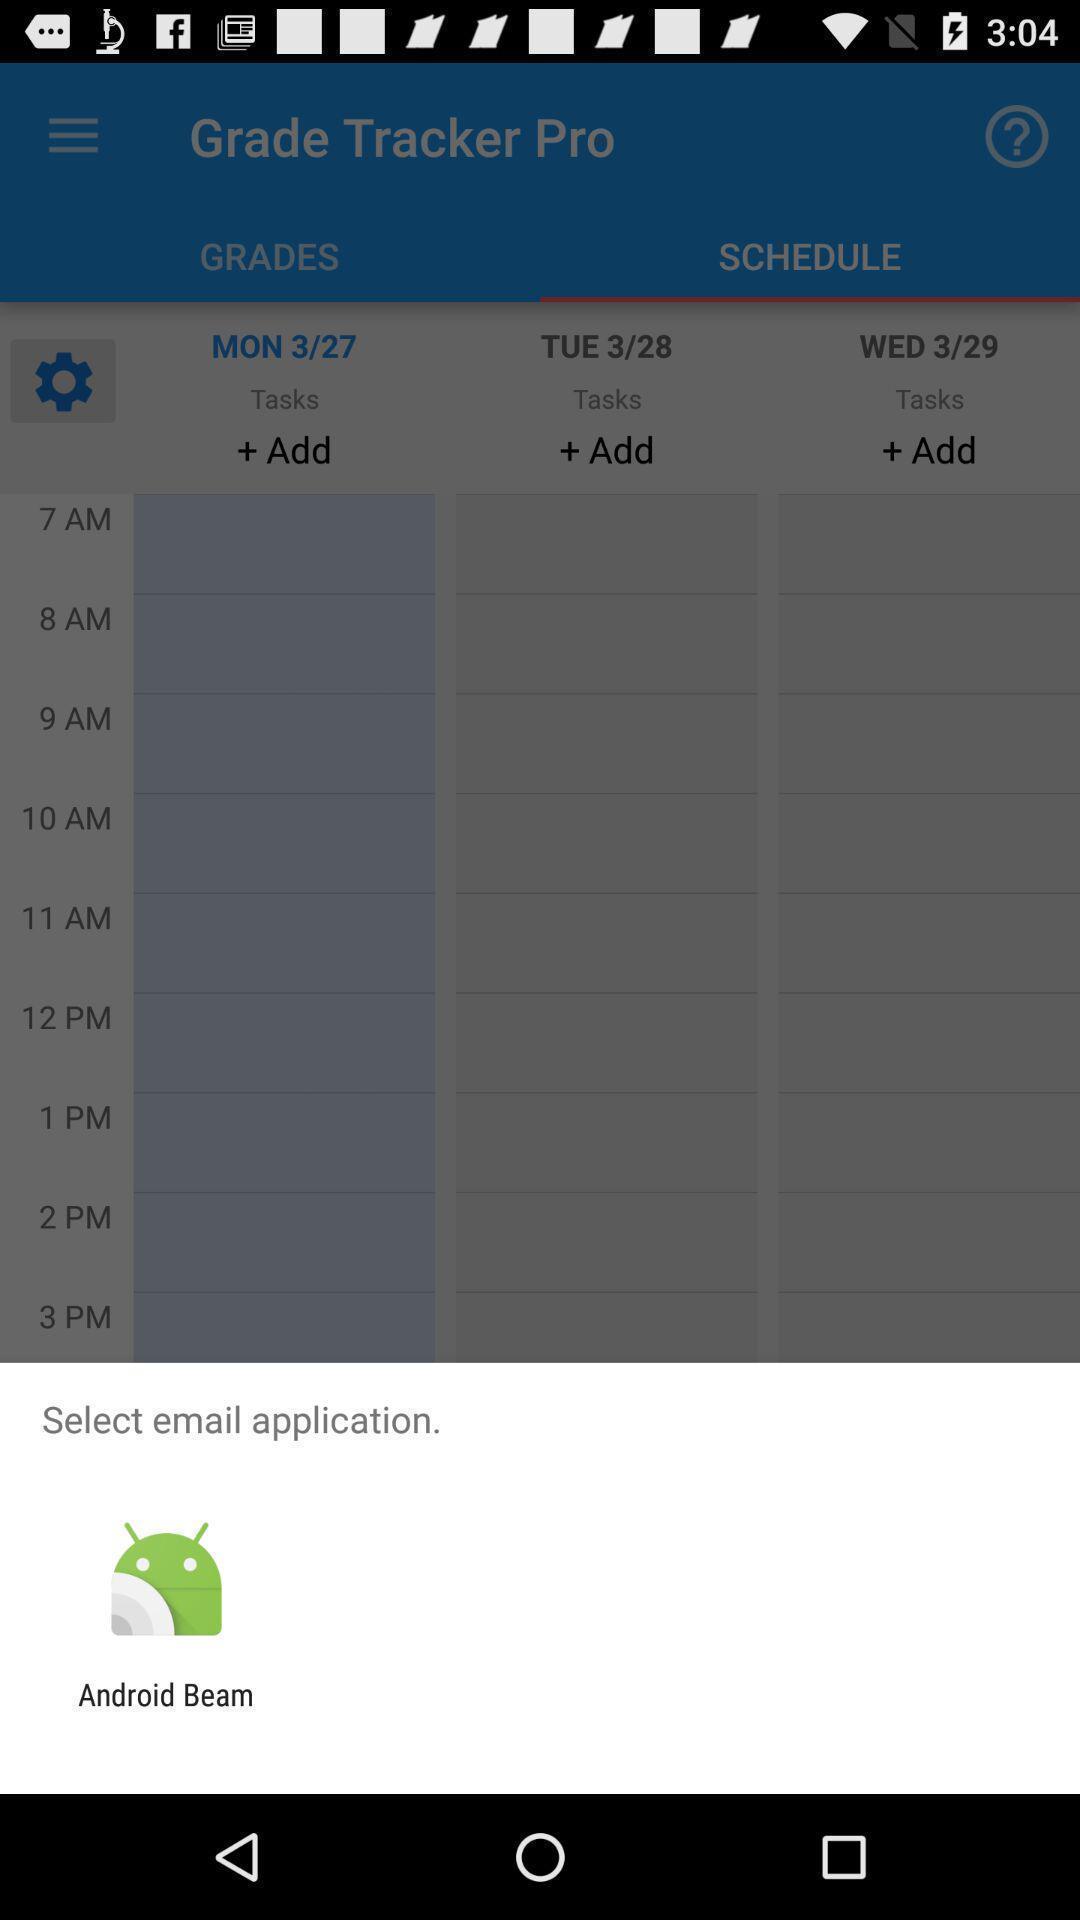What is the overall content of this screenshot? Pop up screen of select email app. 